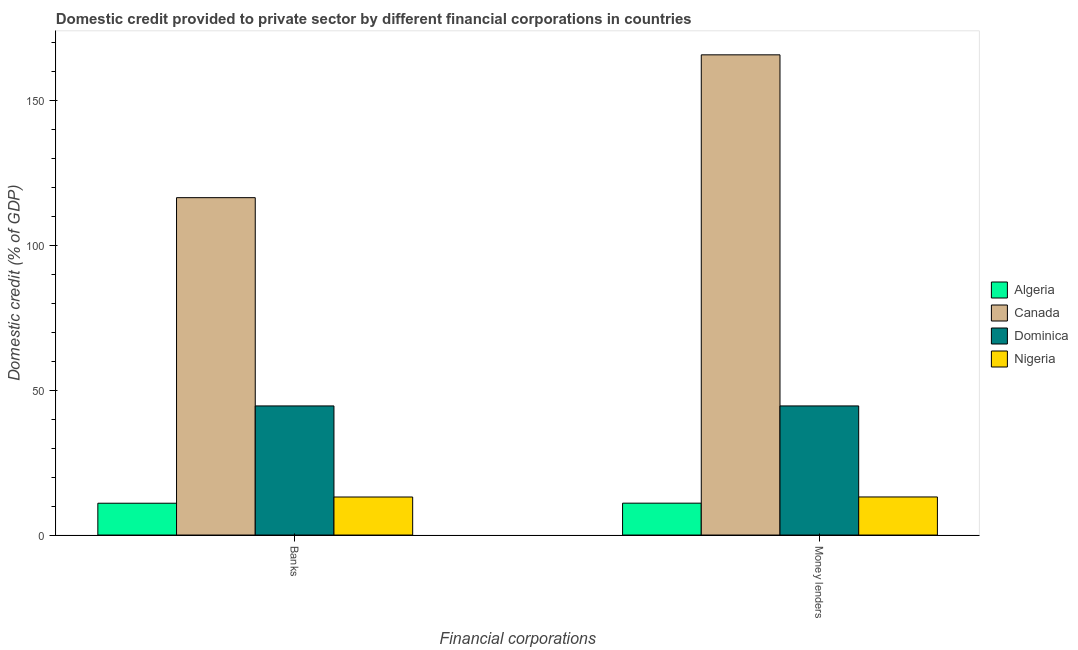How many groups of bars are there?
Keep it short and to the point. 2. Are the number of bars per tick equal to the number of legend labels?
Keep it short and to the point. Yes. How many bars are there on the 2nd tick from the left?
Your answer should be very brief. 4. How many bars are there on the 1st tick from the right?
Your answer should be compact. 4. What is the label of the 1st group of bars from the left?
Keep it short and to the point. Banks. What is the domestic credit provided by banks in Nigeria?
Give a very brief answer. 13.12. Across all countries, what is the maximum domestic credit provided by money lenders?
Ensure brevity in your answer.  165.65. Across all countries, what is the minimum domestic credit provided by banks?
Make the answer very short. 10.97. In which country was the domestic credit provided by money lenders maximum?
Ensure brevity in your answer.  Canada. In which country was the domestic credit provided by money lenders minimum?
Your response must be concise. Algeria. What is the total domestic credit provided by money lenders in the graph?
Your answer should be very brief. 234.32. What is the difference between the domestic credit provided by banks in Algeria and that in Dominica?
Ensure brevity in your answer.  -33.56. What is the difference between the domestic credit provided by banks in Algeria and the domestic credit provided by money lenders in Dominica?
Your response must be concise. -33.56. What is the average domestic credit provided by money lenders per country?
Make the answer very short. 58.58. What is the ratio of the domestic credit provided by banks in Algeria to that in Nigeria?
Offer a very short reply. 0.84. Is the domestic credit provided by banks in Canada less than that in Dominica?
Ensure brevity in your answer.  No. In how many countries, is the domestic credit provided by banks greater than the average domestic credit provided by banks taken over all countries?
Offer a very short reply. 1. What does the 3rd bar from the left in Money lenders represents?
Your answer should be compact. Dominica. What does the 3rd bar from the right in Banks represents?
Ensure brevity in your answer.  Canada. How many bars are there?
Provide a short and direct response. 8. Are all the bars in the graph horizontal?
Make the answer very short. No. How many countries are there in the graph?
Provide a succinct answer. 4. Are the values on the major ticks of Y-axis written in scientific E-notation?
Provide a succinct answer. No. Does the graph contain grids?
Offer a terse response. No. Where does the legend appear in the graph?
Your answer should be compact. Center right. How many legend labels are there?
Your response must be concise. 4. How are the legend labels stacked?
Keep it short and to the point. Vertical. What is the title of the graph?
Provide a succinct answer. Domestic credit provided to private sector by different financial corporations in countries. Does "Tajikistan" appear as one of the legend labels in the graph?
Keep it short and to the point. No. What is the label or title of the X-axis?
Your answer should be compact. Financial corporations. What is the label or title of the Y-axis?
Offer a terse response. Domestic credit (% of GDP). What is the Domestic credit (% of GDP) of Algeria in Banks?
Offer a very short reply. 10.97. What is the Domestic credit (% of GDP) of Canada in Banks?
Provide a short and direct response. 116.38. What is the Domestic credit (% of GDP) of Dominica in Banks?
Offer a very short reply. 44.54. What is the Domestic credit (% of GDP) in Nigeria in Banks?
Your answer should be very brief. 13.12. What is the Domestic credit (% of GDP) in Algeria in Money lenders?
Offer a terse response. 11. What is the Domestic credit (% of GDP) of Canada in Money lenders?
Offer a terse response. 165.65. What is the Domestic credit (% of GDP) in Dominica in Money lenders?
Offer a terse response. 44.54. What is the Domestic credit (% of GDP) of Nigeria in Money lenders?
Make the answer very short. 13.14. Across all Financial corporations, what is the maximum Domestic credit (% of GDP) of Algeria?
Your answer should be very brief. 11. Across all Financial corporations, what is the maximum Domestic credit (% of GDP) of Canada?
Offer a terse response. 165.65. Across all Financial corporations, what is the maximum Domestic credit (% of GDP) of Dominica?
Offer a terse response. 44.54. Across all Financial corporations, what is the maximum Domestic credit (% of GDP) in Nigeria?
Offer a terse response. 13.14. Across all Financial corporations, what is the minimum Domestic credit (% of GDP) of Algeria?
Your response must be concise. 10.97. Across all Financial corporations, what is the minimum Domestic credit (% of GDP) of Canada?
Make the answer very short. 116.38. Across all Financial corporations, what is the minimum Domestic credit (% of GDP) of Dominica?
Your answer should be very brief. 44.54. Across all Financial corporations, what is the minimum Domestic credit (% of GDP) in Nigeria?
Keep it short and to the point. 13.12. What is the total Domestic credit (% of GDP) in Algeria in the graph?
Offer a terse response. 21.97. What is the total Domestic credit (% of GDP) in Canada in the graph?
Your answer should be very brief. 282.03. What is the total Domestic credit (% of GDP) in Dominica in the graph?
Your answer should be very brief. 89.07. What is the total Domestic credit (% of GDP) in Nigeria in the graph?
Offer a terse response. 26.26. What is the difference between the Domestic credit (% of GDP) of Algeria in Banks and that in Money lenders?
Offer a terse response. -0.03. What is the difference between the Domestic credit (% of GDP) of Canada in Banks and that in Money lenders?
Make the answer very short. -49.27. What is the difference between the Domestic credit (% of GDP) in Dominica in Banks and that in Money lenders?
Keep it short and to the point. 0. What is the difference between the Domestic credit (% of GDP) of Nigeria in Banks and that in Money lenders?
Make the answer very short. -0.02. What is the difference between the Domestic credit (% of GDP) in Algeria in Banks and the Domestic credit (% of GDP) in Canada in Money lenders?
Provide a succinct answer. -154.68. What is the difference between the Domestic credit (% of GDP) in Algeria in Banks and the Domestic credit (% of GDP) in Dominica in Money lenders?
Make the answer very short. -33.56. What is the difference between the Domestic credit (% of GDP) of Algeria in Banks and the Domestic credit (% of GDP) of Nigeria in Money lenders?
Your answer should be very brief. -2.16. What is the difference between the Domestic credit (% of GDP) of Canada in Banks and the Domestic credit (% of GDP) of Dominica in Money lenders?
Make the answer very short. 71.85. What is the difference between the Domestic credit (% of GDP) in Canada in Banks and the Domestic credit (% of GDP) in Nigeria in Money lenders?
Make the answer very short. 103.25. What is the difference between the Domestic credit (% of GDP) in Dominica in Banks and the Domestic credit (% of GDP) in Nigeria in Money lenders?
Your answer should be compact. 31.4. What is the average Domestic credit (% of GDP) in Algeria per Financial corporations?
Your answer should be very brief. 10.99. What is the average Domestic credit (% of GDP) of Canada per Financial corporations?
Make the answer very short. 141.02. What is the average Domestic credit (% of GDP) in Dominica per Financial corporations?
Your response must be concise. 44.54. What is the average Domestic credit (% of GDP) in Nigeria per Financial corporations?
Your answer should be compact. 13.13. What is the difference between the Domestic credit (% of GDP) in Algeria and Domestic credit (% of GDP) in Canada in Banks?
Your answer should be compact. -105.41. What is the difference between the Domestic credit (% of GDP) of Algeria and Domestic credit (% of GDP) of Dominica in Banks?
Offer a terse response. -33.56. What is the difference between the Domestic credit (% of GDP) in Algeria and Domestic credit (% of GDP) in Nigeria in Banks?
Provide a succinct answer. -2.15. What is the difference between the Domestic credit (% of GDP) of Canada and Domestic credit (% of GDP) of Dominica in Banks?
Offer a very short reply. 71.85. What is the difference between the Domestic credit (% of GDP) of Canada and Domestic credit (% of GDP) of Nigeria in Banks?
Keep it short and to the point. 103.26. What is the difference between the Domestic credit (% of GDP) in Dominica and Domestic credit (% of GDP) in Nigeria in Banks?
Make the answer very short. 31.42. What is the difference between the Domestic credit (% of GDP) in Algeria and Domestic credit (% of GDP) in Canada in Money lenders?
Ensure brevity in your answer.  -154.65. What is the difference between the Domestic credit (% of GDP) of Algeria and Domestic credit (% of GDP) of Dominica in Money lenders?
Offer a very short reply. -33.54. What is the difference between the Domestic credit (% of GDP) of Algeria and Domestic credit (% of GDP) of Nigeria in Money lenders?
Your answer should be compact. -2.14. What is the difference between the Domestic credit (% of GDP) in Canada and Domestic credit (% of GDP) in Dominica in Money lenders?
Offer a very short reply. 121.11. What is the difference between the Domestic credit (% of GDP) in Canada and Domestic credit (% of GDP) in Nigeria in Money lenders?
Provide a short and direct response. 152.51. What is the difference between the Domestic credit (% of GDP) in Dominica and Domestic credit (% of GDP) in Nigeria in Money lenders?
Offer a very short reply. 31.4. What is the ratio of the Domestic credit (% of GDP) in Canada in Banks to that in Money lenders?
Give a very brief answer. 0.7. What is the ratio of the Domestic credit (% of GDP) in Nigeria in Banks to that in Money lenders?
Keep it short and to the point. 1. What is the difference between the highest and the second highest Domestic credit (% of GDP) in Algeria?
Offer a very short reply. 0.03. What is the difference between the highest and the second highest Domestic credit (% of GDP) of Canada?
Ensure brevity in your answer.  49.27. What is the difference between the highest and the second highest Domestic credit (% of GDP) of Nigeria?
Make the answer very short. 0.02. What is the difference between the highest and the lowest Domestic credit (% of GDP) in Algeria?
Your answer should be very brief. 0.03. What is the difference between the highest and the lowest Domestic credit (% of GDP) of Canada?
Provide a succinct answer. 49.27. What is the difference between the highest and the lowest Domestic credit (% of GDP) of Nigeria?
Offer a very short reply. 0.02. 